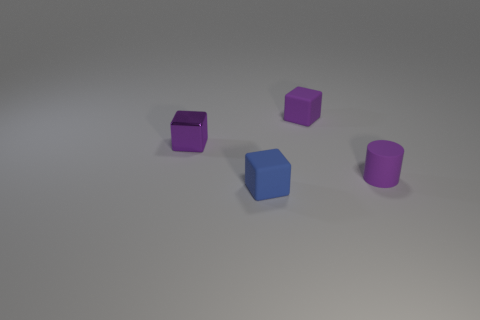Subtract all rubber blocks. How many blocks are left? 1 Subtract all cylinders. How many objects are left? 3 Add 4 small purple rubber things. How many small purple rubber things exist? 6 Add 1 small cubes. How many objects exist? 5 Subtract all purple blocks. How many blocks are left? 1 Subtract 0 red cubes. How many objects are left? 4 Subtract 1 cylinders. How many cylinders are left? 0 Subtract all gray blocks. Subtract all purple cylinders. How many blocks are left? 3 Subtract all green spheres. How many purple blocks are left? 2 Subtract all red shiny things. Subtract all tiny objects. How many objects are left? 0 